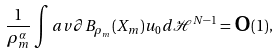<formula> <loc_0><loc_0><loc_500><loc_500>\frac { 1 } { \rho _ { m } ^ { \alpha } } \int a v { \partial B _ { \rho _ { m } } ( X _ { m } ) } u _ { 0 } d \mathcal { H } ^ { N - 1 } = \text {o} ( 1 ) ,</formula> 